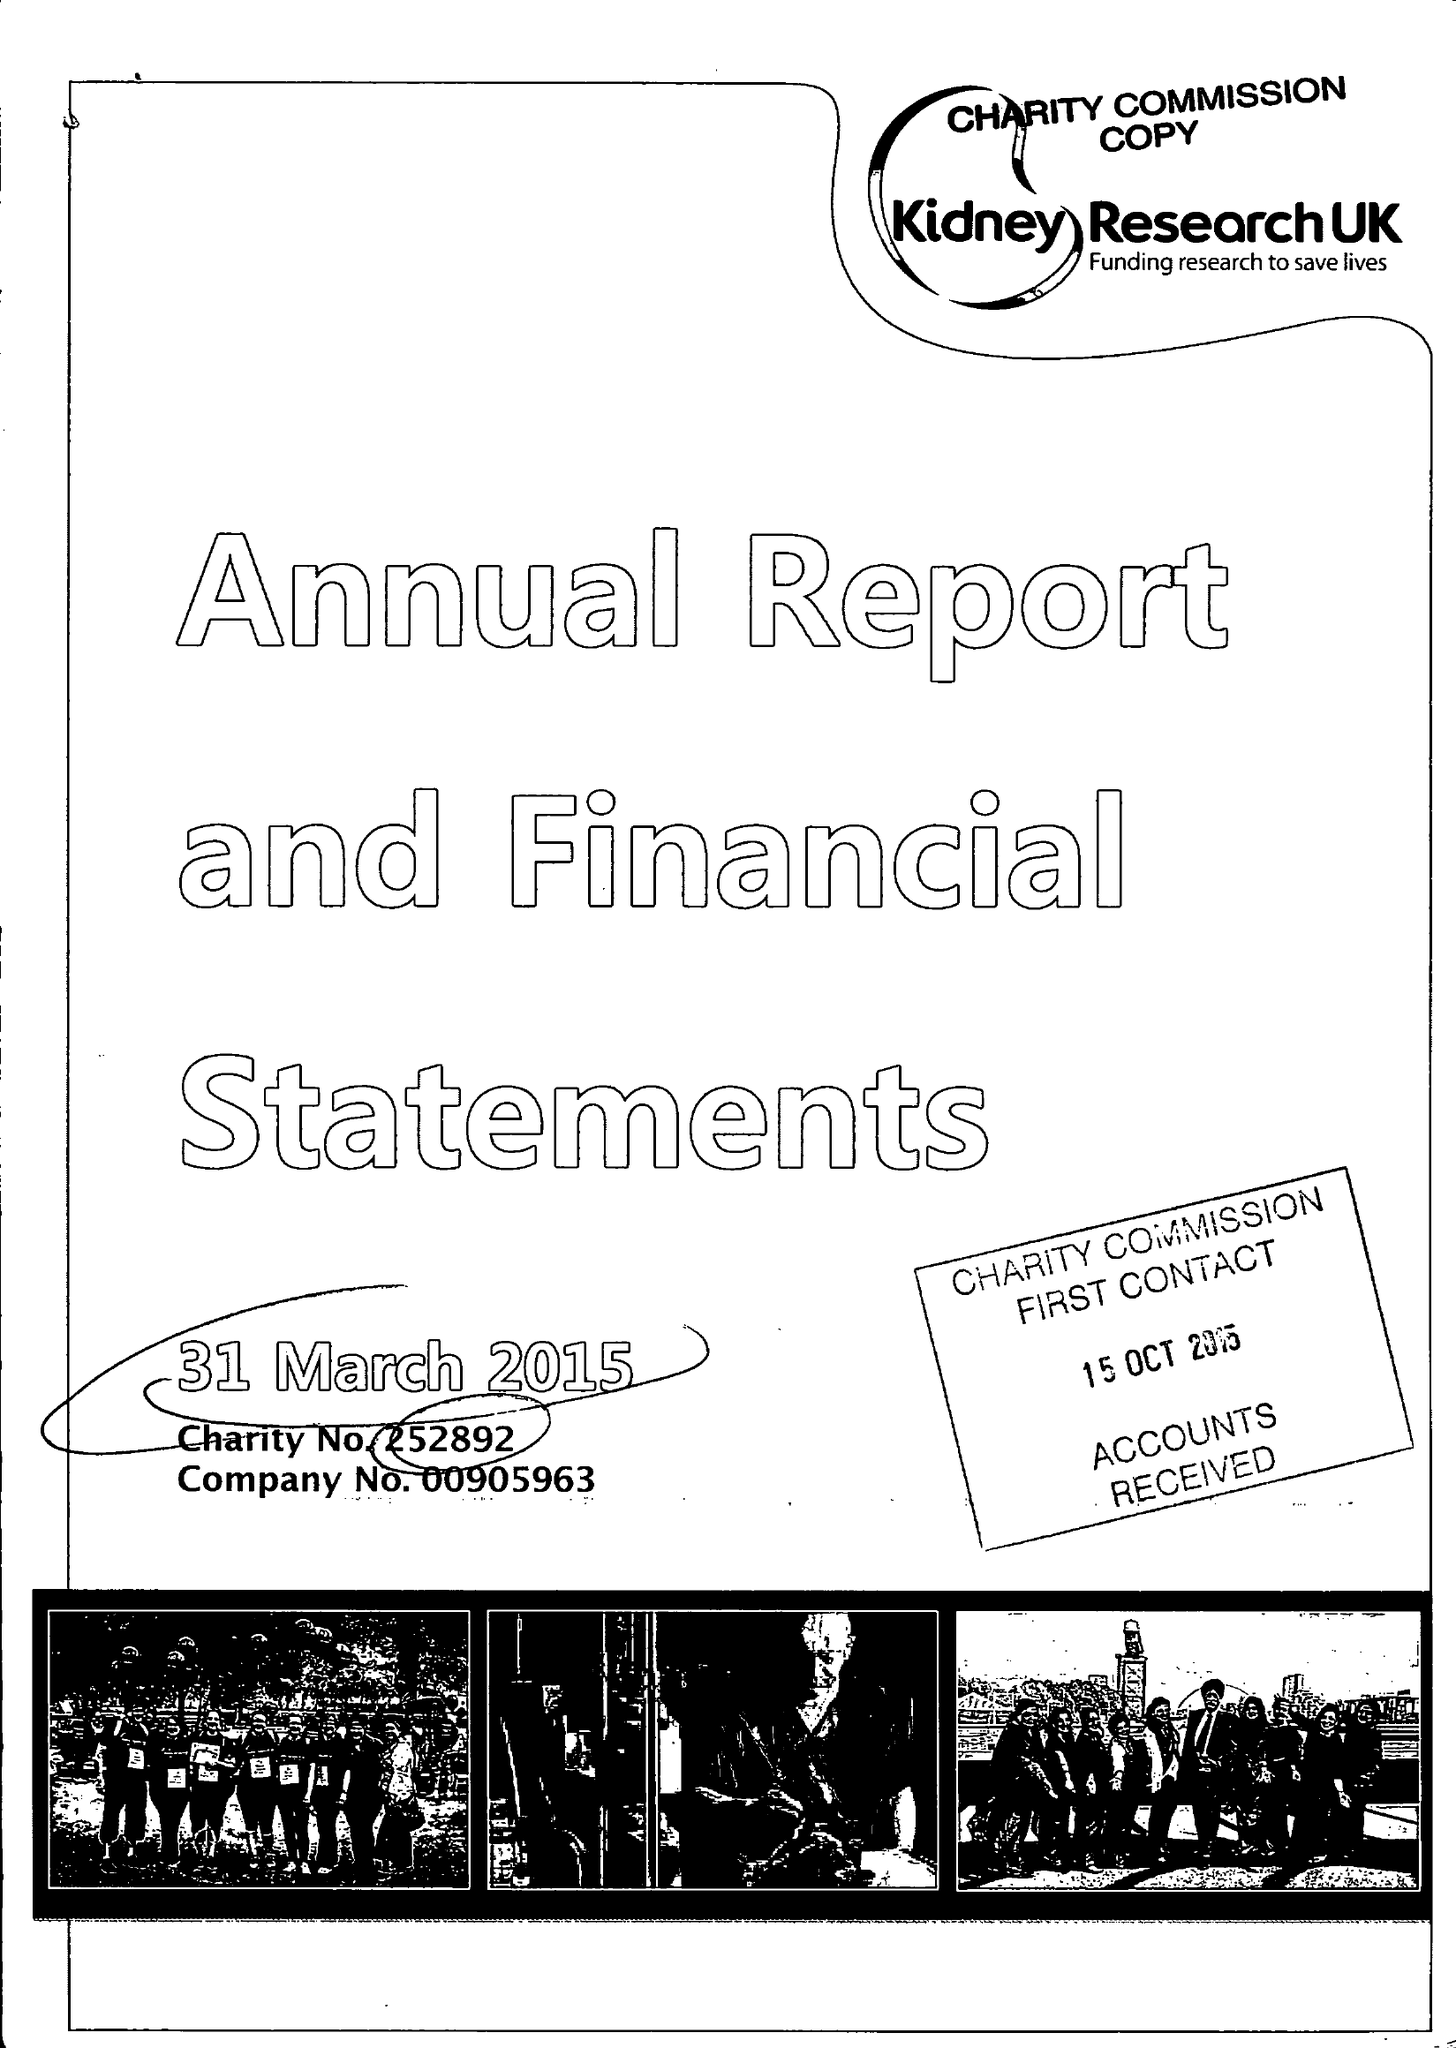What is the value for the charity_number?
Answer the question using a single word or phrase. 252892 